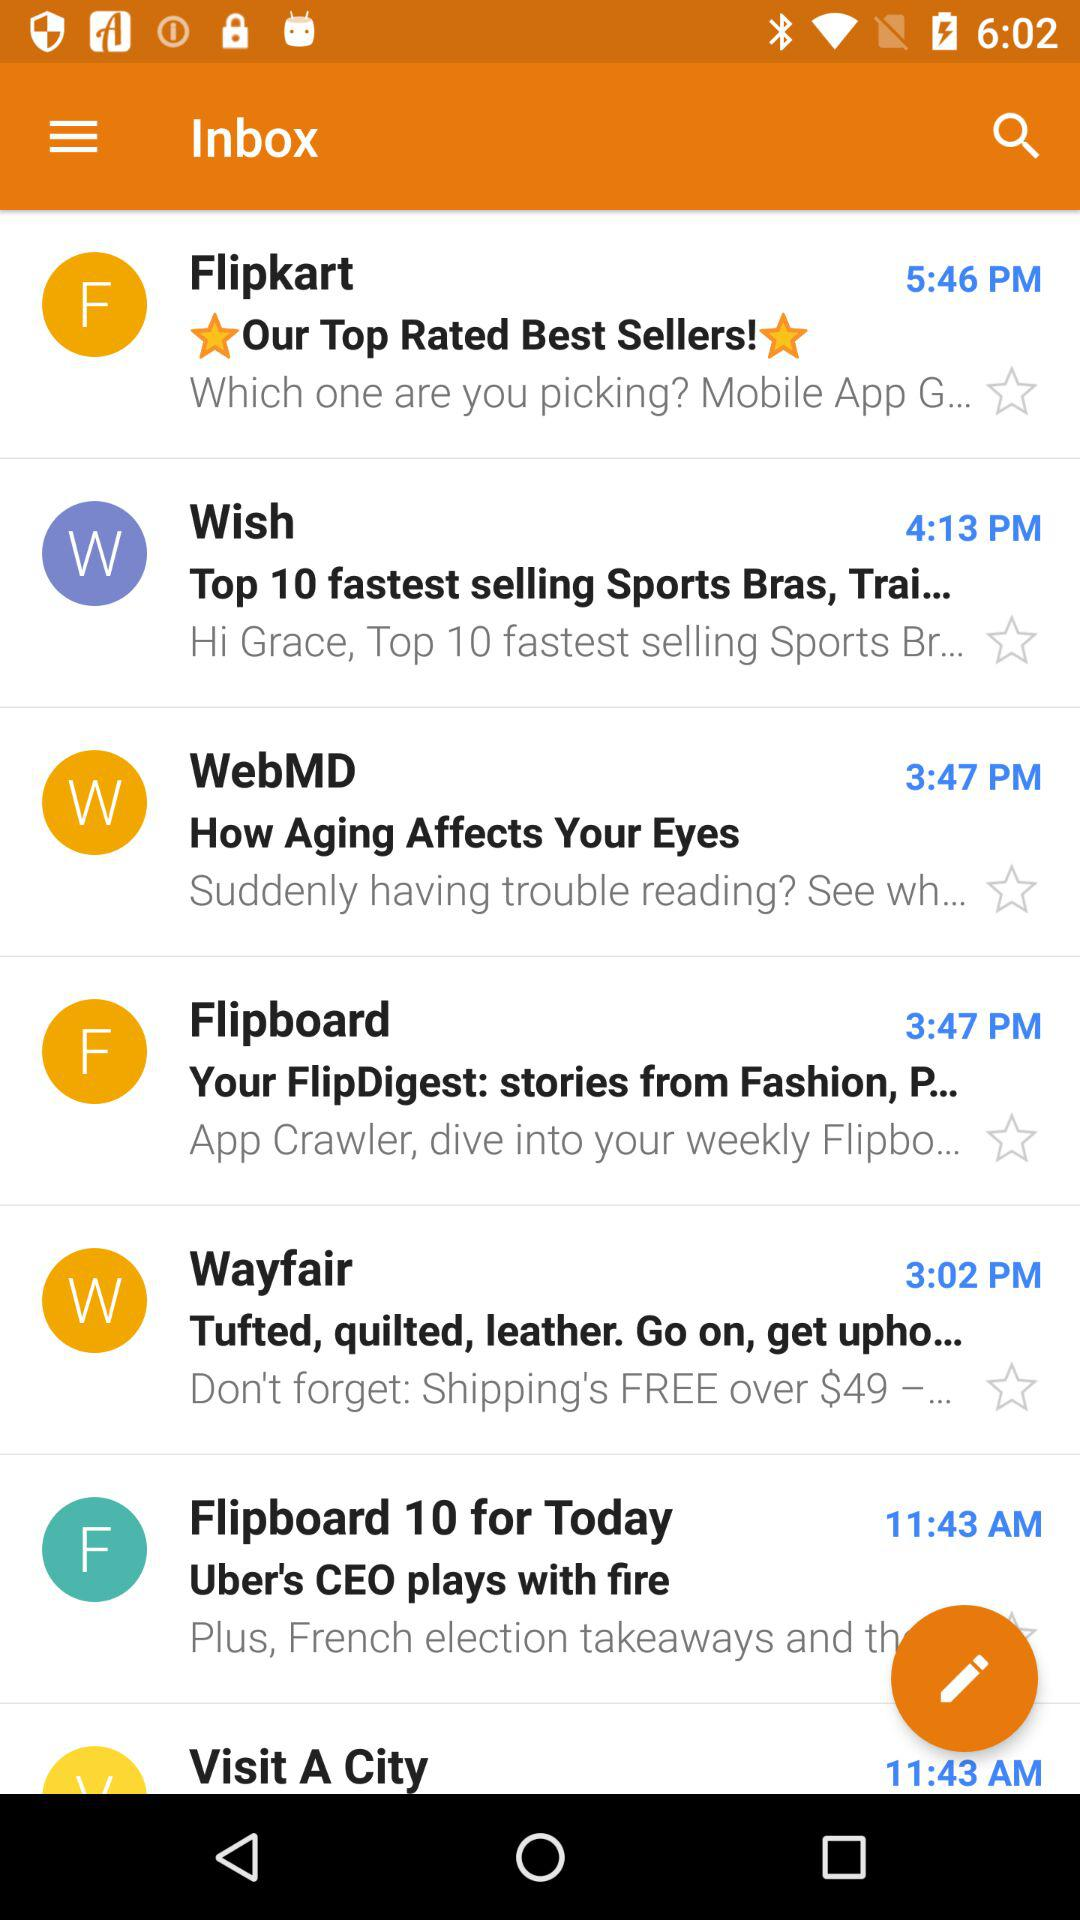How many items are from the same app?
Answer the question using a single word or phrase. 2 